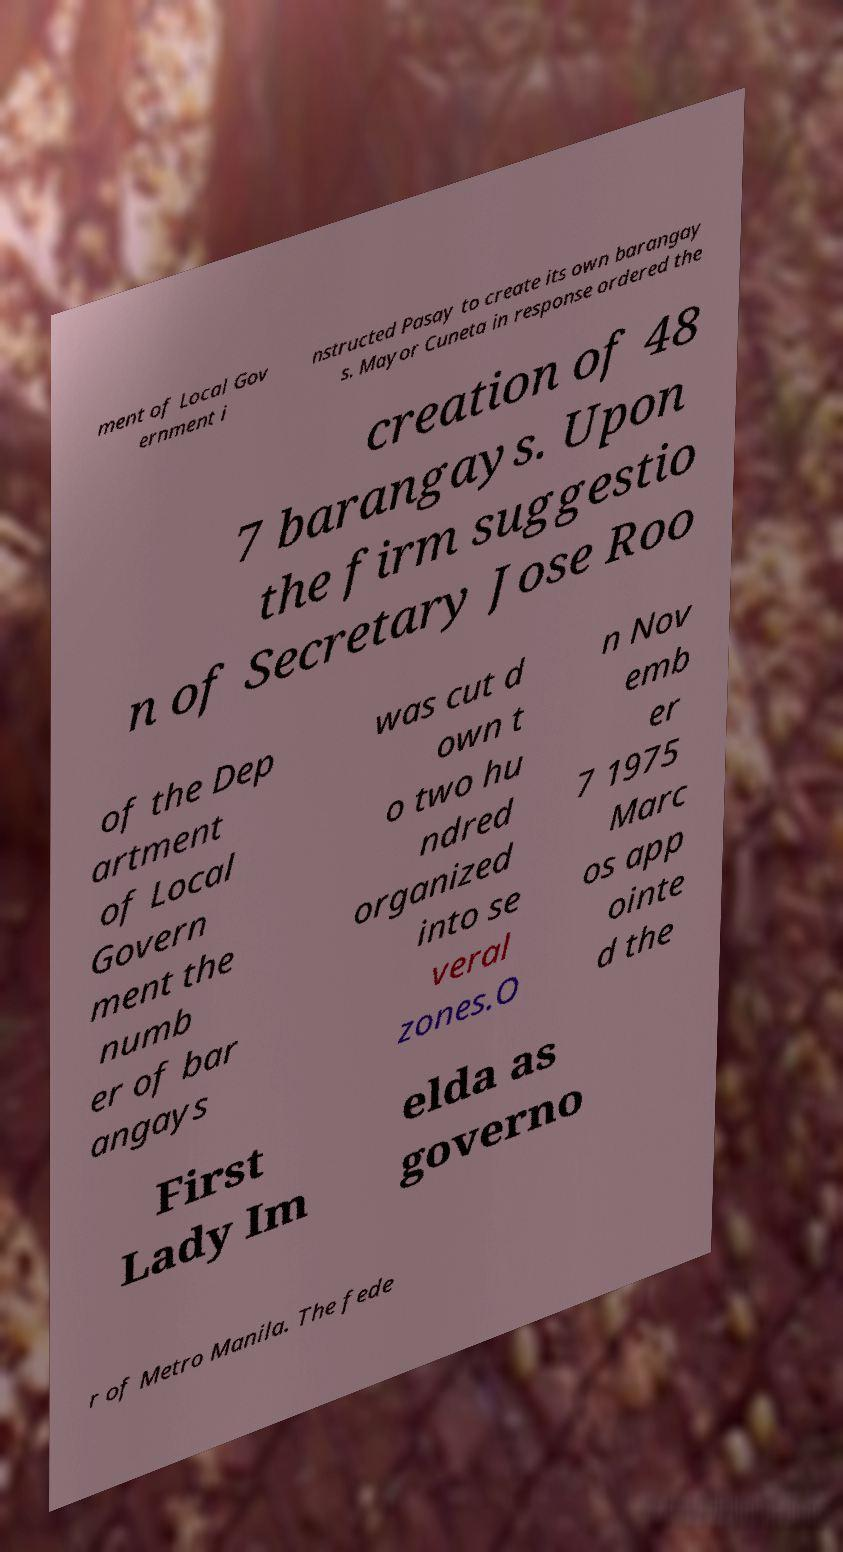What messages or text are displayed in this image? I need them in a readable, typed format. ment of Local Gov ernment i nstructed Pasay to create its own barangay s. Mayor Cuneta in response ordered the creation of 48 7 barangays. Upon the firm suggestio n of Secretary Jose Roo of the Dep artment of Local Govern ment the numb er of bar angays was cut d own t o two hu ndred organized into se veral zones.O n Nov emb er 7 1975 Marc os app ointe d the First Lady Im elda as governo r of Metro Manila. The fede 